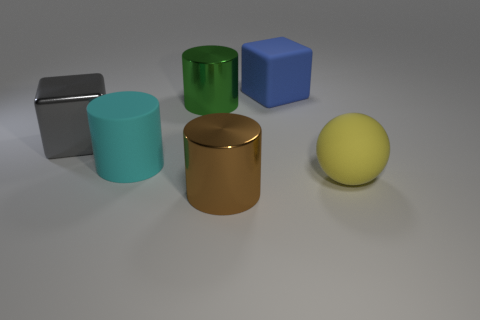What size is the brown object that is the same shape as the cyan object?
Your answer should be compact. Large. Is there any other thing that has the same size as the rubber sphere?
Your response must be concise. Yes. What number of objects are large cylinders left of the brown metallic object or big objects that are behind the large brown shiny thing?
Provide a short and direct response. 5. Are there more large cyan matte objects than large metallic cylinders?
Provide a short and direct response. No. What number of other objects are the same color as the large rubber ball?
Provide a succinct answer. 0. What number of objects are red shiny balls or big yellow spheres?
Make the answer very short. 1. There is a matte object that is left of the big blue block; is it the same shape as the brown thing?
Provide a succinct answer. Yes. There is a big block in front of the block that is on the right side of the brown shiny thing; what color is it?
Give a very brief answer. Gray. Is the number of big blue matte objects less than the number of tiny cyan blocks?
Your answer should be compact. No. Is there a large cylinder that has the same material as the large gray thing?
Make the answer very short. Yes. 